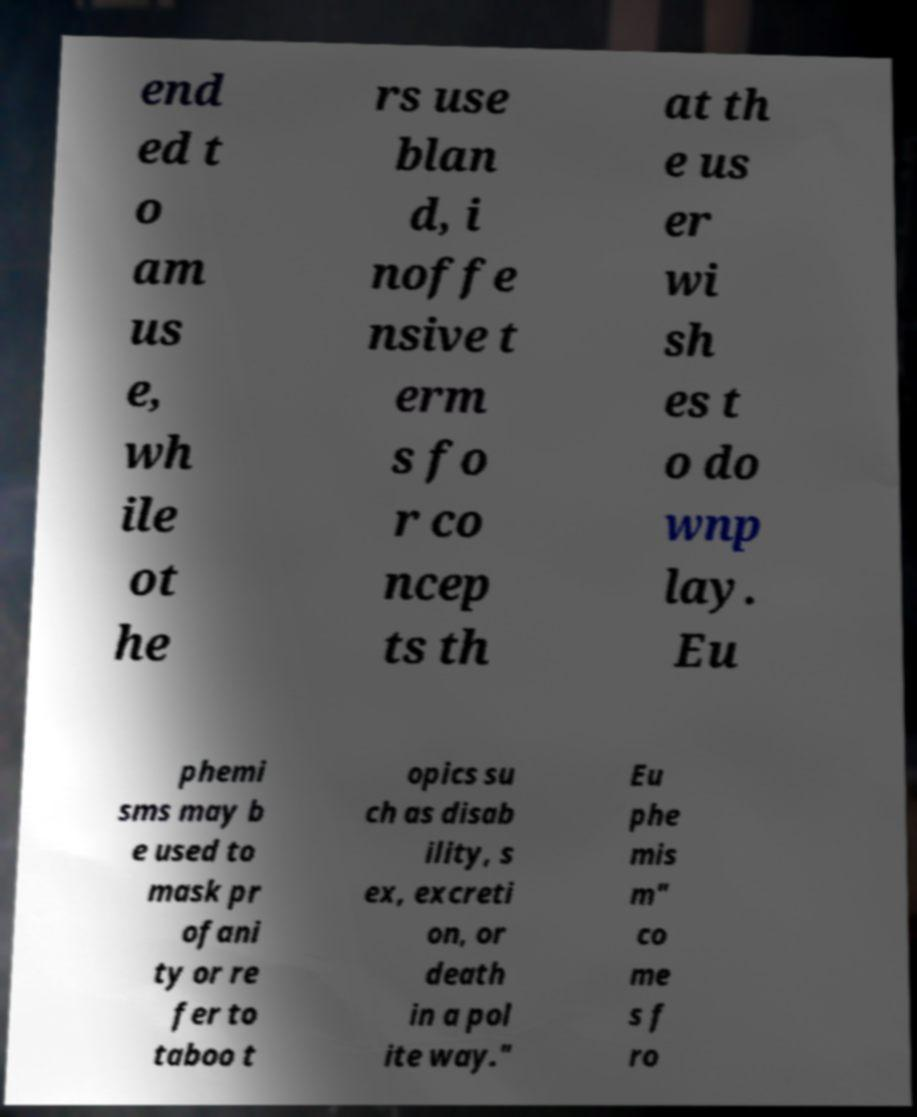Could you extract and type out the text from this image? end ed t o am us e, wh ile ot he rs use blan d, i noffe nsive t erm s fo r co ncep ts th at th e us er wi sh es t o do wnp lay. Eu phemi sms may b e used to mask pr ofani ty or re fer to taboo t opics su ch as disab ility, s ex, excreti on, or death in a pol ite way." Eu phe mis m" co me s f ro 